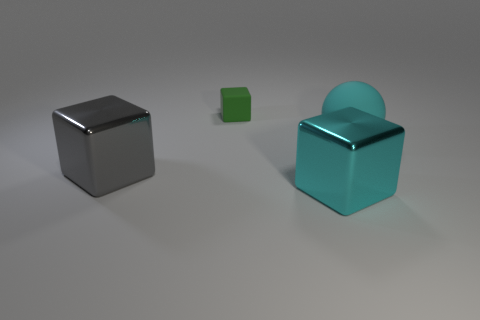Add 1 big purple metallic cylinders. How many objects exist? 5 Subtract all cubes. How many objects are left? 1 Subtract all cyan rubber objects. Subtract all cyan cubes. How many objects are left? 2 Add 1 small rubber objects. How many small rubber objects are left? 2 Add 1 large yellow rubber spheres. How many large yellow rubber spheres exist? 1 Subtract 0 yellow balls. How many objects are left? 4 